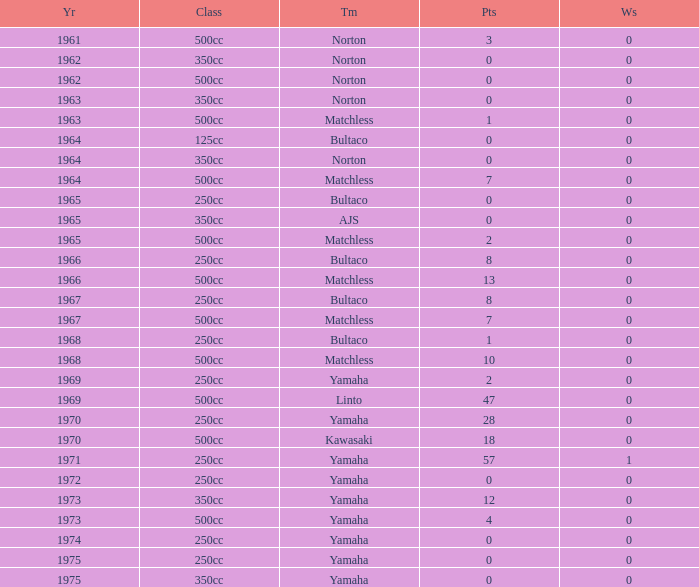What is the average wins in 250cc class for Bultaco with 8 points later than 1966? 0.0. 